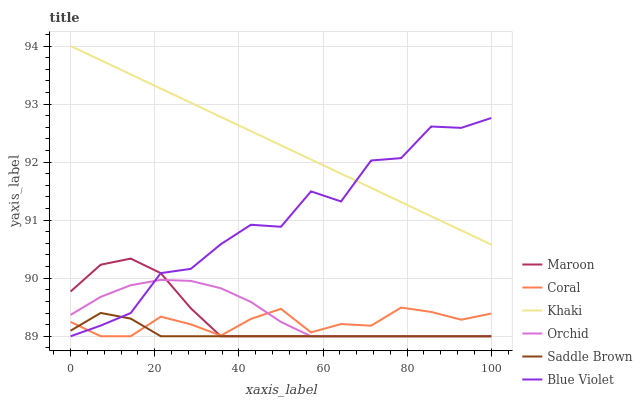Does Coral have the minimum area under the curve?
Answer yes or no. No. Does Coral have the maximum area under the curve?
Answer yes or no. No. Is Coral the smoothest?
Answer yes or no. No. Is Coral the roughest?
Answer yes or no. No. Does Coral have the highest value?
Answer yes or no. No. Is Saddle Brown less than Khaki?
Answer yes or no. Yes. Is Khaki greater than Orchid?
Answer yes or no. Yes. Does Saddle Brown intersect Khaki?
Answer yes or no. No. 